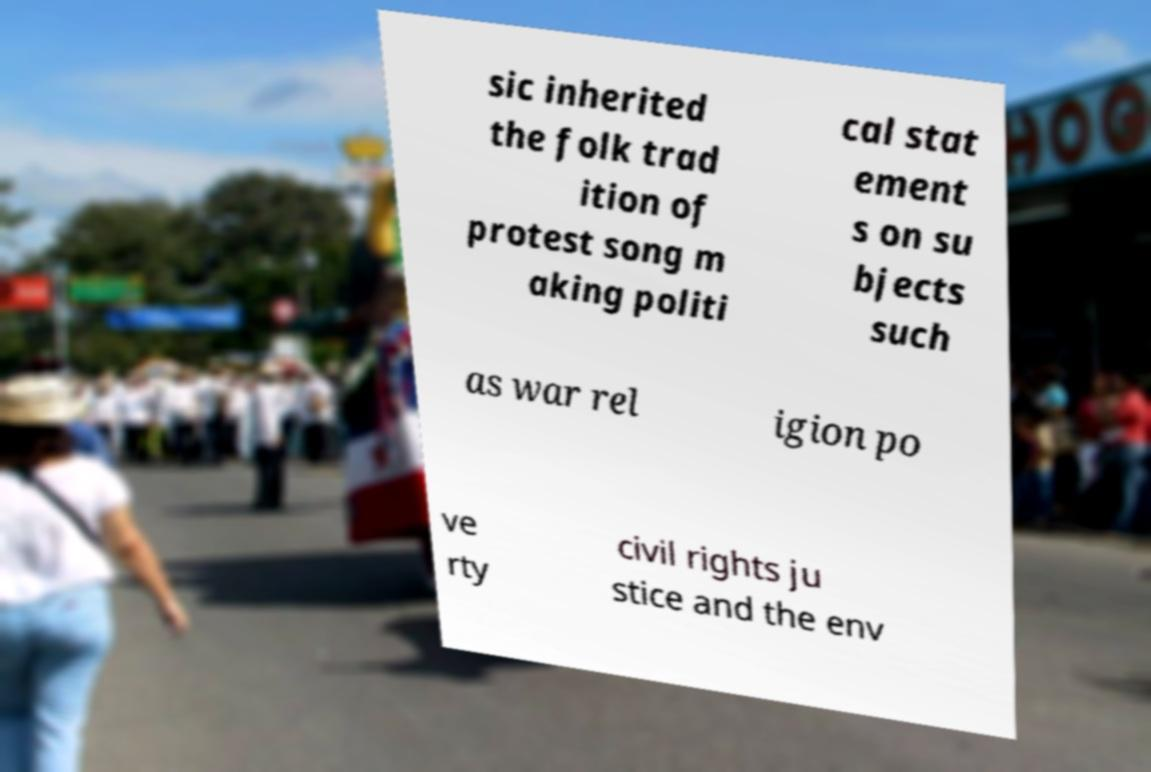Please identify and transcribe the text found in this image. sic inherited the folk trad ition of protest song m aking politi cal stat ement s on su bjects such as war rel igion po ve rty civil rights ju stice and the env 